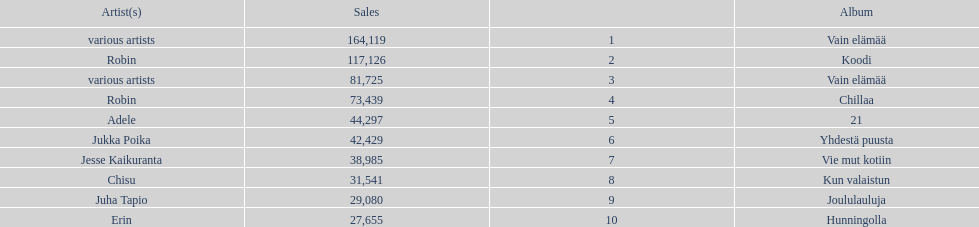Tell me what album had the most sold. Vain elämää. 